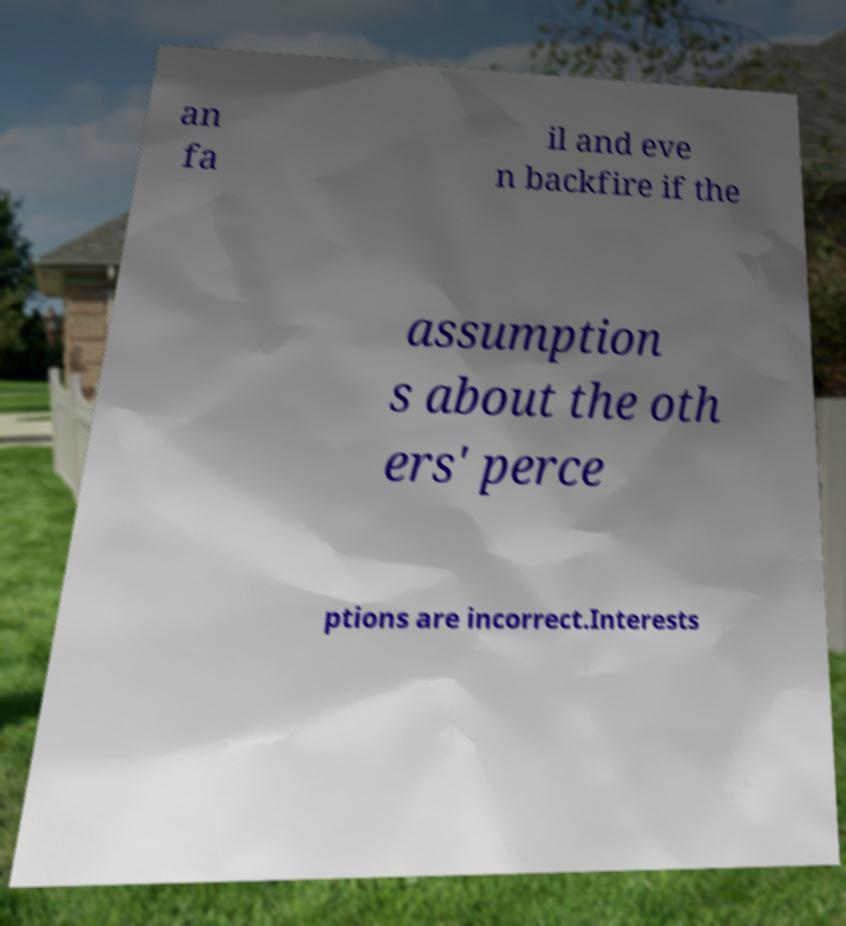There's text embedded in this image that I need extracted. Can you transcribe it verbatim? an fa il and eve n backfire if the assumption s about the oth ers' perce ptions are incorrect.Interests 